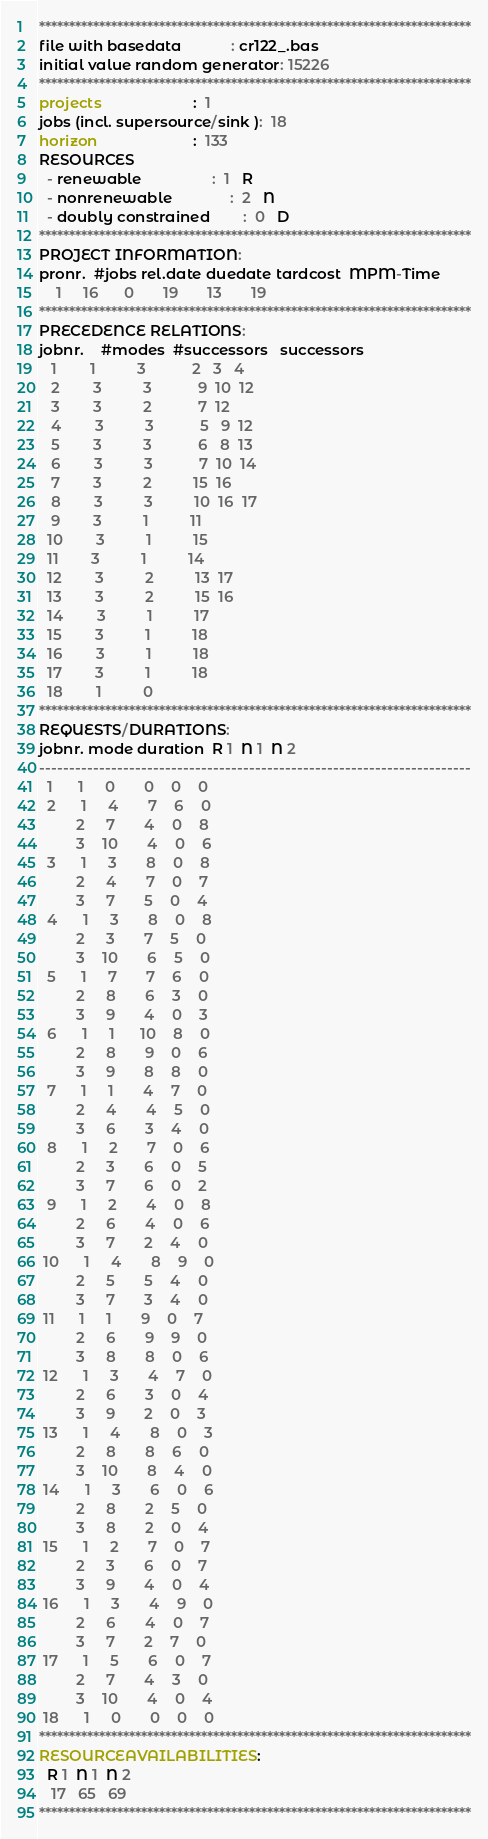Convert code to text. <code><loc_0><loc_0><loc_500><loc_500><_ObjectiveC_>************************************************************************
file with basedata            : cr122_.bas
initial value random generator: 15226
************************************************************************
projects                      :  1
jobs (incl. supersource/sink ):  18
horizon                       :  133
RESOURCES
  - renewable                 :  1   R
  - nonrenewable              :  2   N
  - doubly constrained        :  0   D
************************************************************************
PROJECT INFORMATION:
pronr.  #jobs rel.date duedate tardcost  MPM-Time
    1     16      0       19       13       19
************************************************************************
PRECEDENCE RELATIONS:
jobnr.    #modes  #successors   successors
   1        1          3           2   3   4
   2        3          3           9  10  12
   3        3          2           7  12
   4        3          3           5   9  12
   5        3          3           6   8  13
   6        3          3           7  10  14
   7        3          2          15  16
   8        3          3          10  16  17
   9        3          1          11
  10        3          1          15
  11        3          1          14
  12        3          2          13  17
  13        3          2          15  16
  14        3          1          17
  15        3          1          18
  16        3          1          18
  17        3          1          18
  18        1          0        
************************************************************************
REQUESTS/DURATIONS:
jobnr. mode duration  R 1  N 1  N 2
------------------------------------------------------------------------
  1      1     0       0    0    0
  2      1     4       7    6    0
         2     7       4    0    8
         3    10       4    0    6
  3      1     3       8    0    8
         2     4       7    0    7
         3     7       5    0    4
  4      1     3       8    0    8
         2     3       7    5    0
         3    10       6    5    0
  5      1     7       7    6    0
         2     8       6    3    0
         3     9       4    0    3
  6      1     1      10    8    0
         2     8       9    0    6
         3     9       8    8    0
  7      1     1       4    7    0
         2     4       4    5    0
         3     6       3    4    0
  8      1     2       7    0    6
         2     3       6    0    5
         3     7       6    0    2
  9      1     2       4    0    8
         2     6       4    0    6
         3     7       2    4    0
 10      1     4       8    9    0
         2     5       5    4    0
         3     7       3    4    0
 11      1     1       9    0    7
         2     6       9    9    0
         3     8       8    0    6
 12      1     3       4    7    0
         2     6       3    0    4
         3     9       2    0    3
 13      1     4       8    0    3
         2     8       8    6    0
         3    10       8    4    0
 14      1     3       6    0    6
         2     8       2    5    0
         3     8       2    0    4
 15      1     2       7    0    7
         2     3       6    0    7
         3     9       4    0    4
 16      1     3       4    9    0
         2     6       4    0    7
         3     7       2    7    0
 17      1     5       6    0    7
         2     7       4    3    0
         3    10       4    0    4
 18      1     0       0    0    0
************************************************************************
RESOURCEAVAILABILITIES:
  R 1  N 1  N 2
   17   65   69
************************************************************************
</code> 